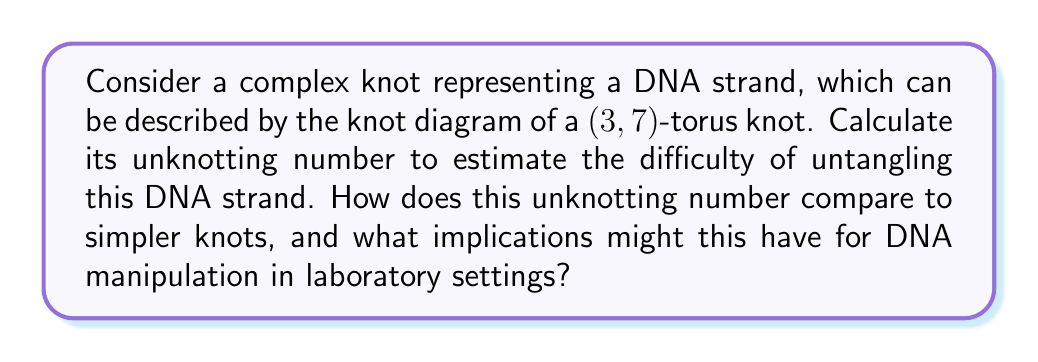What is the answer to this math problem? To calculate the unknotting number of the (3,7)-torus knot and understand its implications, let's follow these steps:

1. Recall the formula for the unknotting number of a (p,q)-torus knot:
   $$ u(T(p,q)) = \frac{(p-1)(q-1)}{2} $$
   where p and q are coprime positive integers.

2. In our case, p = 3 and q = 7. Substitute these values:
   $$ u(T(3,7)) = \frac{(3-1)(7-1)}{2} = \frac{2 \cdot 6}{2} = 6 $$

3. The unknotting number of 6 means that a minimum of 6 crossing changes are required to transform this knot into an unknot.

4. Compare this to simpler knots:
   - Trefoil knot (3,2)-torus knot: $u(T(3,2)) = 1$
   - Figure-eight knot: $u = 1$
   - Cinquefoil knot (5,2)-torus knot: $u(T(5,2)) = 2$

5. Implications for DNA manipulation:
   a) The (3,7)-torus knot is significantly more complex than simpler knots, requiring more manipulations to untangle.
   b) This higher unknotting number suggests that DNA strands forming such complex knots would be more challenging to manipulate in laboratory settings.
   c) Increased difficulty in untangling may lead to higher risks of DNA damage during manipulation processes.
   d) More time and resources may be required for experiments involving DNA with complex knotting.
   e) Special care and advanced techniques might be necessary when working with highly knotted DNA structures to maintain integrity and avoid unintended consequences.
Answer: Unknotting number: 6. Significantly higher than simpler knots, implying increased difficulty and potential risks in DNA manipulation. 